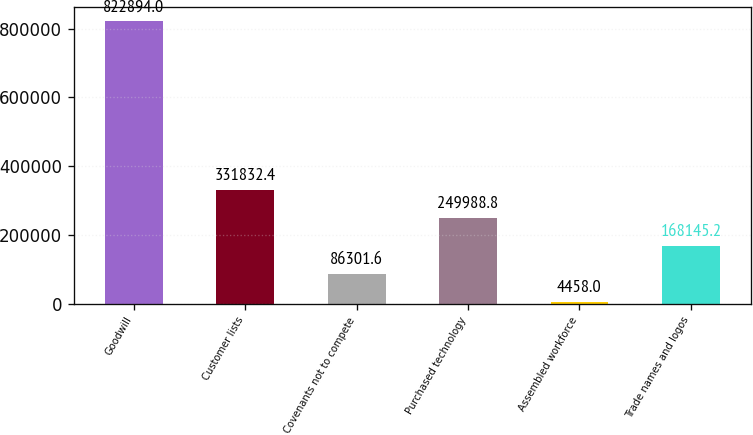Convert chart. <chart><loc_0><loc_0><loc_500><loc_500><bar_chart><fcel>Goodwill<fcel>Customer lists<fcel>Covenants not to compete<fcel>Purchased technology<fcel>Assembled workforce<fcel>Trade names and logos<nl><fcel>822894<fcel>331832<fcel>86301.6<fcel>249989<fcel>4458<fcel>168145<nl></chart> 